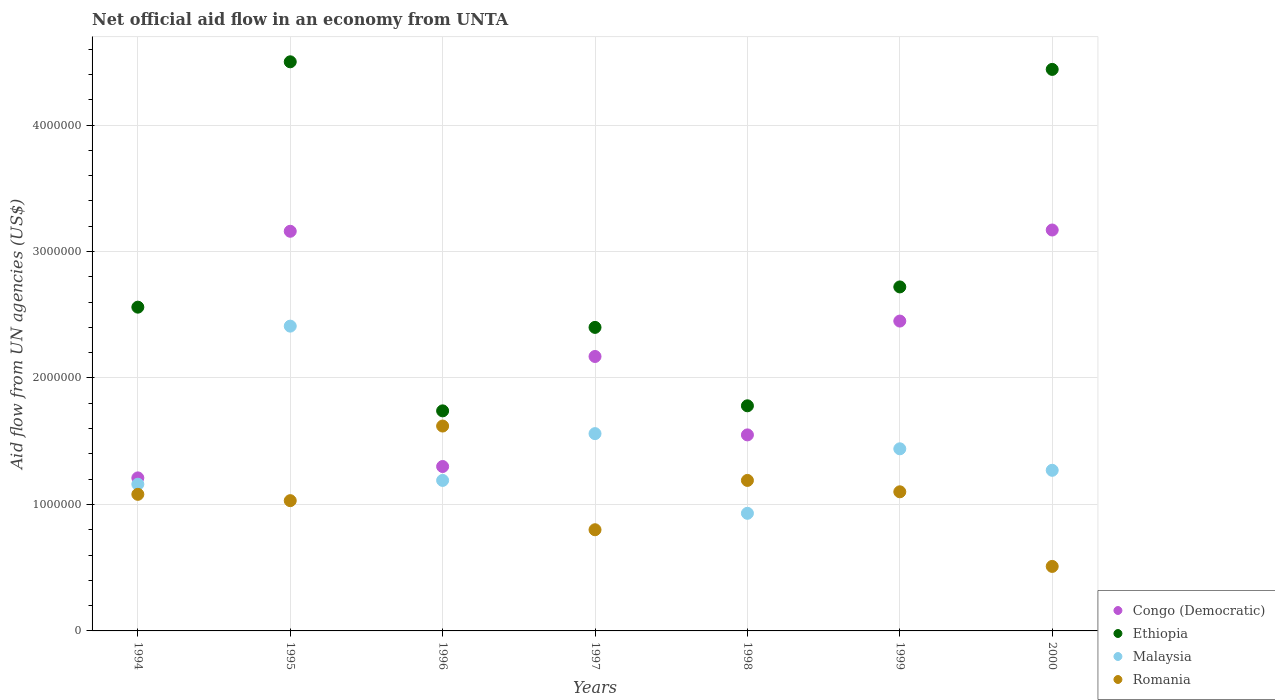What is the net official aid flow in Malaysia in 1999?
Offer a terse response. 1.44e+06. Across all years, what is the maximum net official aid flow in Congo (Democratic)?
Provide a succinct answer. 3.17e+06. Across all years, what is the minimum net official aid flow in Ethiopia?
Offer a terse response. 1.74e+06. What is the total net official aid flow in Congo (Democratic) in the graph?
Provide a short and direct response. 1.50e+07. What is the difference between the net official aid flow in Ethiopia in 1995 and that in 1996?
Your response must be concise. 2.76e+06. What is the difference between the net official aid flow in Romania in 1998 and the net official aid flow in Ethiopia in 2000?
Your response must be concise. -3.25e+06. What is the average net official aid flow in Ethiopia per year?
Your answer should be compact. 2.88e+06. In the year 1994, what is the difference between the net official aid flow in Ethiopia and net official aid flow in Romania?
Your answer should be compact. 1.48e+06. In how many years, is the net official aid flow in Ethiopia greater than 1600000 US$?
Provide a short and direct response. 7. What is the ratio of the net official aid flow in Malaysia in 1994 to that in 1997?
Your answer should be very brief. 0.74. What is the difference between the highest and the second highest net official aid flow in Ethiopia?
Your answer should be compact. 6.00e+04. What is the difference between the highest and the lowest net official aid flow in Romania?
Offer a very short reply. 1.11e+06. In how many years, is the net official aid flow in Romania greater than the average net official aid flow in Romania taken over all years?
Offer a very short reply. 4. Is the sum of the net official aid flow in Malaysia in 1998 and 2000 greater than the maximum net official aid flow in Ethiopia across all years?
Make the answer very short. No. Is it the case that in every year, the sum of the net official aid flow in Ethiopia and net official aid flow in Malaysia  is greater than the sum of net official aid flow in Congo (Democratic) and net official aid flow in Romania?
Provide a short and direct response. Yes. Is it the case that in every year, the sum of the net official aid flow in Malaysia and net official aid flow in Congo (Democratic)  is greater than the net official aid flow in Ethiopia?
Offer a very short reply. No. Is the net official aid flow in Ethiopia strictly less than the net official aid flow in Romania over the years?
Offer a very short reply. No. Where does the legend appear in the graph?
Your answer should be compact. Bottom right. How are the legend labels stacked?
Make the answer very short. Vertical. What is the title of the graph?
Keep it short and to the point. Net official aid flow in an economy from UNTA. Does "Tanzania" appear as one of the legend labels in the graph?
Offer a terse response. No. What is the label or title of the Y-axis?
Offer a very short reply. Aid flow from UN agencies (US$). What is the Aid flow from UN agencies (US$) of Congo (Democratic) in 1994?
Provide a short and direct response. 1.21e+06. What is the Aid flow from UN agencies (US$) in Ethiopia in 1994?
Your answer should be very brief. 2.56e+06. What is the Aid flow from UN agencies (US$) in Malaysia in 1994?
Offer a terse response. 1.16e+06. What is the Aid flow from UN agencies (US$) in Romania in 1994?
Make the answer very short. 1.08e+06. What is the Aid flow from UN agencies (US$) of Congo (Democratic) in 1995?
Offer a terse response. 3.16e+06. What is the Aid flow from UN agencies (US$) of Ethiopia in 1995?
Your response must be concise. 4.50e+06. What is the Aid flow from UN agencies (US$) in Malaysia in 1995?
Give a very brief answer. 2.41e+06. What is the Aid flow from UN agencies (US$) in Romania in 1995?
Give a very brief answer. 1.03e+06. What is the Aid flow from UN agencies (US$) of Congo (Democratic) in 1996?
Your answer should be compact. 1.30e+06. What is the Aid flow from UN agencies (US$) of Ethiopia in 1996?
Provide a succinct answer. 1.74e+06. What is the Aid flow from UN agencies (US$) in Malaysia in 1996?
Provide a succinct answer. 1.19e+06. What is the Aid flow from UN agencies (US$) of Romania in 1996?
Provide a succinct answer. 1.62e+06. What is the Aid flow from UN agencies (US$) in Congo (Democratic) in 1997?
Give a very brief answer. 2.17e+06. What is the Aid flow from UN agencies (US$) of Ethiopia in 1997?
Your answer should be compact. 2.40e+06. What is the Aid flow from UN agencies (US$) in Malaysia in 1997?
Provide a succinct answer. 1.56e+06. What is the Aid flow from UN agencies (US$) in Congo (Democratic) in 1998?
Give a very brief answer. 1.55e+06. What is the Aid flow from UN agencies (US$) of Ethiopia in 1998?
Provide a short and direct response. 1.78e+06. What is the Aid flow from UN agencies (US$) in Malaysia in 1998?
Your answer should be compact. 9.30e+05. What is the Aid flow from UN agencies (US$) in Romania in 1998?
Your response must be concise. 1.19e+06. What is the Aid flow from UN agencies (US$) in Congo (Democratic) in 1999?
Provide a succinct answer. 2.45e+06. What is the Aid flow from UN agencies (US$) of Ethiopia in 1999?
Keep it short and to the point. 2.72e+06. What is the Aid flow from UN agencies (US$) of Malaysia in 1999?
Offer a very short reply. 1.44e+06. What is the Aid flow from UN agencies (US$) of Romania in 1999?
Your answer should be compact. 1.10e+06. What is the Aid flow from UN agencies (US$) in Congo (Democratic) in 2000?
Keep it short and to the point. 3.17e+06. What is the Aid flow from UN agencies (US$) of Ethiopia in 2000?
Provide a succinct answer. 4.44e+06. What is the Aid flow from UN agencies (US$) in Malaysia in 2000?
Your answer should be compact. 1.27e+06. What is the Aid flow from UN agencies (US$) in Romania in 2000?
Offer a very short reply. 5.10e+05. Across all years, what is the maximum Aid flow from UN agencies (US$) of Congo (Democratic)?
Offer a terse response. 3.17e+06. Across all years, what is the maximum Aid flow from UN agencies (US$) of Ethiopia?
Your response must be concise. 4.50e+06. Across all years, what is the maximum Aid flow from UN agencies (US$) in Malaysia?
Provide a succinct answer. 2.41e+06. Across all years, what is the maximum Aid flow from UN agencies (US$) of Romania?
Your answer should be compact. 1.62e+06. Across all years, what is the minimum Aid flow from UN agencies (US$) of Congo (Democratic)?
Offer a terse response. 1.21e+06. Across all years, what is the minimum Aid flow from UN agencies (US$) in Ethiopia?
Your answer should be compact. 1.74e+06. Across all years, what is the minimum Aid flow from UN agencies (US$) in Malaysia?
Keep it short and to the point. 9.30e+05. Across all years, what is the minimum Aid flow from UN agencies (US$) in Romania?
Your answer should be compact. 5.10e+05. What is the total Aid flow from UN agencies (US$) of Congo (Democratic) in the graph?
Your answer should be very brief. 1.50e+07. What is the total Aid flow from UN agencies (US$) of Ethiopia in the graph?
Make the answer very short. 2.01e+07. What is the total Aid flow from UN agencies (US$) of Malaysia in the graph?
Your response must be concise. 9.96e+06. What is the total Aid flow from UN agencies (US$) in Romania in the graph?
Give a very brief answer. 7.33e+06. What is the difference between the Aid flow from UN agencies (US$) in Congo (Democratic) in 1994 and that in 1995?
Offer a terse response. -1.95e+06. What is the difference between the Aid flow from UN agencies (US$) in Ethiopia in 1994 and that in 1995?
Offer a very short reply. -1.94e+06. What is the difference between the Aid flow from UN agencies (US$) of Malaysia in 1994 and that in 1995?
Provide a succinct answer. -1.25e+06. What is the difference between the Aid flow from UN agencies (US$) in Congo (Democratic) in 1994 and that in 1996?
Your answer should be compact. -9.00e+04. What is the difference between the Aid flow from UN agencies (US$) of Ethiopia in 1994 and that in 1996?
Ensure brevity in your answer.  8.20e+05. What is the difference between the Aid flow from UN agencies (US$) in Romania in 1994 and that in 1996?
Provide a short and direct response. -5.40e+05. What is the difference between the Aid flow from UN agencies (US$) in Congo (Democratic) in 1994 and that in 1997?
Give a very brief answer. -9.60e+05. What is the difference between the Aid flow from UN agencies (US$) in Ethiopia in 1994 and that in 1997?
Your response must be concise. 1.60e+05. What is the difference between the Aid flow from UN agencies (US$) in Malaysia in 1994 and that in 1997?
Your answer should be compact. -4.00e+05. What is the difference between the Aid flow from UN agencies (US$) in Romania in 1994 and that in 1997?
Your answer should be compact. 2.80e+05. What is the difference between the Aid flow from UN agencies (US$) in Ethiopia in 1994 and that in 1998?
Offer a very short reply. 7.80e+05. What is the difference between the Aid flow from UN agencies (US$) of Romania in 1994 and that in 1998?
Your response must be concise. -1.10e+05. What is the difference between the Aid flow from UN agencies (US$) of Congo (Democratic) in 1994 and that in 1999?
Your response must be concise. -1.24e+06. What is the difference between the Aid flow from UN agencies (US$) in Ethiopia in 1994 and that in 1999?
Give a very brief answer. -1.60e+05. What is the difference between the Aid flow from UN agencies (US$) of Malaysia in 1994 and that in 1999?
Your response must be concise. -2.80e+05. What is the difference between the Aid flow from UN agencies (US$) of Congo (Democratic) in 1994 and that in 2000?
Ensure brevity in your answer.  -1.96e+06. What is the difference between the Aid flow from UN agencies (US$) of Ethiopia in 1994 and that in 2000?
Your answer should be compact. -1.88e+06. What is the difference between the Aid flow from UN agencies (US$) of Malaysia in 1994 and that in 2000?
Your response must be concise. -1.10e+05. What is the difference between the Aid flow from UN agencies (US$) of Romania in 1994 and that in 2000?
Your answer should be compact. 5.70e+05. What is the difference between the Aid flow from UN agencies (US$) of Congo (Democratic) in 1995 and that in 1996?
Your answer should be compact. 1.86e+06. What is the difference between the Aid flow from UN agencies (US$) of Ethiopia in 1995 and that in 1996?
Offer a terse response. 2.76e+06. What is the difference between the Aid flow from UN agencies (US$) in Malaysia in 1995 and that in 1996?
Your response must be concise. 1.22e+06. What is the difference between the Aid flow from UN agencies (US$) in Romania in 1995 and that in 1996?
Your answer should be compact. -5.90e+05. What is the difference between the Aid flow from UN agencies (US$) of Congo (Democratic) in 1995 and that in 1997?
Offer a very short reply. 9.90e+05. What is the difference between the Aid flow from UN agencies (US$) of Ethiopia in 1995 and that in 1997?
Make the answer very short. 2.10e+06. What is the difference between the Aid flow from UN agencies (US$) in Malaysia in 1995 and that in 1997?
Your answer should be very brief. 8.50e+05. What is the difference between the Aid flow from UN agencies (US$) of Congo (Democratic) in 1995 and that in 1998?
Offer a terse response. 1.61e+06. What is the difference between the Aid flow from UN agencies (US$) of Ethiopia in 1995 and that in 1998?
Your answer should be compact. 2.72e+06. What is the difference between the Aid flow from UN agencies (US$) in Malaysia in 1995 and that in 1998?
Provide a short and direct response. 1.48e+06. What is the difference between the Aid flow from UN agencies (US$) of Romania in 1995 and that in 1998?
Provide a succinct answer. -1.60e+05. What is the difference between the Aid flow from UN agencies (US$) of Congo (Democratic) in 1995 and that in 1999?
Your response must be concise. 7.10e+05. What is the difference between the Aid flow from UN agencies (US$) in Ethiopia in 1995 and that in 1999?
Offer a very short reply. 1.78e+06. What is the difference between the Aid flow from UN agencies (US$) in Malaysia in 1995 and that in 1999?
Your response must be concise. 9.70e+05. What is the difference between the Aid flow from UN agencies (US$) in Congo (Democratic) in 1995 and that in 2000?
Provide a short and direct response. -10000. What is the difference between the Aid flow from UN agencies (US$) of Ethiopia in 1995 and that in 2000?
Offer a terse response. 6.00e+04. What is the difference between the Aid flow from UN agencies (US$) in Malaysia in 1995 and that in 2000?
Provide a succinct answer. 1.14e+06. What is the difference between the Aid flow from UN agencies (US$) in Romania in 1995 and that in 2000?
Your answer should be very brief. 5.20e+05. What is the difference between the Aid flow from UN agencies (US$) in Congo (Democratic) in 1996 and that in 1997?
Provide a short and direct response. -8.70e+05. What is the difference between the Aid flow from UN agencies (US$) of Ethiopia in 1996 and that in 1997?
Give a very brief answer. -6.60e+05. What is the difference between the Aid flow from UN agencies (US$) of Malaysia in 1996 and that in 1997?
Your answer should be compact. -3.70e+05. What is the difference between the Aid flow from UN agencies (US$) in Romania in 1996 and that in 1997?
Your answer should be compact. 8.20e+05. What is the difference between the Aid flow from UN agencies (US$) of Congo (Democratic) in 1996 and that in 1999?
Keep it short and to the point. -1.15e+06. What is the difference between the Aid flow from UN agencies (US$) of Ethiopia in 1996 and that in 1999?
Your response must be concise. -9.80e+05. What is the difference between the Aid flow from UN agencies (US$) in Malaysia in 1996 and that in 1999?
Offer a terse response. -2.50e+05. What is the difference between the Aid flow from UN agencies (US$) of Romania in 1996 and that in 1999?
Keep it short and to the point. 5.20e+05. What is the difference between the Aid flow from UN agencies (US$) of Congo (Democratic) in 1996 and that in 2000?
Ensure brevity in your answer.  -1.87e+06. What is the difference between the Aid flow from UN agencies (US$) of Ethiopia in 1996 and that in 2000?
Offer a very short reply. -2.70e+06. What is the difference between the Aid flow from UN agencies (US$) of Malaysia in 1996 and that in 2000?
Provide a short and direct response. -8.00e+04. What is the difference between the Aid flow from UN agencies (US$) of Romania in 1996 and that in 2000?
Your response must be concise. 1.11e+06. What is the difference between the Aid flow from UN agencies (US$) of Congo (Democratic) in 1997 and that in 1998?
Provide a succinct answer. 6.20e+05. What is the difference between the Aid flow from UN agencies (US$) in Ethiopia in 1997 and that in 1998?
Offer a very short reply. 6.20e+05. What is the difference between the Aid flow from UN agencies (US$) in Malaysia in 1997 and that in 1998?
Give a very brief answer. 6.30e+05. What is the difference between the Aid flow from UN agencies (US$) in Romania in 1997 and that in 1998?
Your response must be concise. -3.90e+05. What is the difference between the Aid flow from UN agencies (US$) in Congo (Democratic) in 1997 and that in 1999?
Keep it short and to the point. -2.80e+05. What is the difference between the Aid flow from UN agencies (US$) in Ethiopia in 1997 and that in 1999?
Offer a very short reply. -3.20e+05. What is the difference between the Aid flow from UN agencies (US$) of Malaysia in 1997 and that in 1999?
Provide a succinct answer. 1.20e+05. What is the difference between the Aid flow from UN agencies (US$) in Ethiopia in 1997 and that in 2000?
Your response must be concise. -2.04e+06. What is the difference between the Aid flow from UN agencies (US$) of Congo (Democratic) in 1998 and that in 1999?
Keep it short and to the point. -9.00e+05. What is the difference between the Aid flow from UN agencies (US$) of Ethiopia in 1998 and that in 1999?
Your response must be concise. -9.40e+05. What is the difference between the Aid flow from UN agencies (US$) of Malaysia in 1998 and that in 1999?
Ensure brevity in your answer.  -5.10e+05. What is the difference between the Aid flow from UN agencies (US$) of Romania in 1998 and that in 1999?
Ensure brevity in your answer.  9.00e+04. What is the difference between the Aid flow from UN agencies (US$) of Congo (Democratic) in 1998 and that in 2000?
Your answer should be compact. -1.62e+06. What is the difference between the Aid flow from UN agencies (US$) in Ethiopia in 1998 and that in 2000?
Offer a terse response. -2.66e+06. What is the difference between the Aid flow from UN agencies (US$) of Romania in 1998 and that in 2000?
Your response must be concise. 6.80e+05. What is the difference between the Aid flow from UN agencies (US$) in Congo (Democratic) in 1999 and that in 2000?
Offer a terse response. -7.20e+05. What is the difference between the Aid flow from UN agencies (US$) of Ethiopia in 1999 and that in 2000?
Your answer should be very brief. -1.72e+06. What is the difference between the Aid flow from UN agencies (US$) in Romania in 1999 and that in 2000?
Offer a very short reply. 5.90e+05. What is the difference between the Aid flow from UN agencies (US$) of Congo (Democratic) in 1994 and the Aid flow from UN agencies (US$) of Ethiopia in 1995?
Provide a succinct answer. -3.29e+06. What is the difference between the Aid flow from UN agencies (US$) of Congo (Democratic) in 1994 and the Aid flow from UN agencies (US$) of Malaysia in 1995?
Your answer should be very brief. -1.20e+06. What is the difference between the Aid flow from UN agencies (US$) in Ethiopia in 1994 and the Aid flow from UN agencies (US$) in Malaysia in 1995?
Keep it short and to the point. 1.50e+05. What is the difference between the Aid flow from UN agencies (US$) of Ethiopia in 1994 and the Aid flow from UN agencies (US$) of Romania in 1995?
Offer a very short reply. 1.53e+06. What is the difference between the Aid flow from UN agencies (US$) in Malaysia in 1994 and the Aid flow from UN agencies (US$) in Romania in 1995?
Your answer should be compact. 1.30e+05. What is the difference between the Aid flow from UN agencies (US$) in Congo (Democratic) in 1994 and the Aid flow from UN agencies (US$) in Ethiopia in 1996?
Your answer should be very brief. -5.30e+05. What is the difference between the Aid flow from UN agencies (US$) of Congo (Democratic) in 1994 and the Aid flow from UN agencies (US$) of Romania in 1996?
Offer a terse response. -4.10e+05. What is the difference between the Aid flow from UN agencies (US$) in Ethiopia in 1994 and the Aid flow from UN agencies (US$) in Malaysia in 1996?
Ensure brevity in your answer.  1.37e+06. What is the difference between the Aid flow from UN agencies (US$) of Ethiopia in 1994 and the Aid flow from UN agencies (US$) of Romania in 1996?
Offer a very short reply. 9.40e+05. What is the difference between the Aid flow from UN agencies (US$) of Malaysia in 1994 and the Aid flow from UN agencies (US$) of Romania in 1996?
Make the answer very short. -4.60e+05. What is the difference between the Aid flow from UN agencies (US$) of Congo (Democratic) in 1994 and the Aid flow from UN agencies (US$) of Ethiopia in 1997?
Give a very brief answer. -1.19e+06. What is the difference between the Aid flow from UN agencies (US$) of Congo (Democratic) in 1994 and the Aid flow from UN agencies (US$) of Malaysia in 1997?
Give a very brief answer. -3.50e+05. What is the difference between the Aid flow from UN agencies (US$) in Congo (Democratic) in 1994 and the Aid flow from UN agencies (US$) in Romania in 1997?
Your answer should be compact. 4.10e+05. What is the difference between the Aid flow from UN agencies (US$) in Ethiopia in 1994 and the Aid flow from UN agencies (US$) in Romania in 1997?
Offer a terse response. 1.76e+06. What is the difference between the Aid flow from UN agencies (US$) of Malaysia in 1994 and the Aid flow from UN agencies (US$) of Romania in 1997?
Provide a succinct answer. 3.60e+05. What is the difference between the Aid flow from UN agencies (US$) in Congo (Democratic) in 1994 and the Aid flow from UN agencies (US$) in Ethiopia in 1998?
Provide a short and direct response. -5.70e+05. What is the difference between the Aid flow from UN agencies (US$) in Congo (Democratic) in 1994 and the Aid flow from UN agencies (US$) in Romania in 1998?
Your answer should be very brief. 2.00e+04. What is the difference between the Aid flow from UN agencies (US$) in Ethiopia in 1994 and the Aid flow from UN agencies (US$) in Malaysia in 1998?
Your answer should be very brief. 1.63e+06. What is the difference between the Aid flow from UN agencies (US$) in Ethiopia in 1994 and the Aid flow from UN agencies (US$) in Romania in 1998?
Your answer should be very brief. 1.37e+06. What is the difference between the Aid flow from UN agencies (US$) of Congo (Democratic) in 1994 and the Aid flow from UN agencies (US$) of Ethiopia in 1999?
Provide a succinct answer. -1.51e+06. What is the difference between the Aid flow from UN agencies (US$) in Congo (Democratic) in 1994 and the Aid flow from UN agencies (US$) in Malaysia in 1999?
Your answer should be very brief. -2.30e+05. What is the difference between the Aid flow from UN agencies (US$) of Congo (Democratic) in 1994 and the Aid flow from UN agencies (US$) of Romania in 1999?
Ensure brevity in your answer.  1.10e+05. What is the difference between the Aid flow from UN agencies (US$) of Ethiopia in 1994 and the Aid flow from UN agencies (US$) of Malaysia in 1999?
Provide a short and direct response. 1.12e+06. What is the difference between the Aid flow from UN agencies (US$) of Ethiopia in 1994 and the Aid flow from UN agencies (US$) of Romania in 1999?
Offer a terse response. 1.46e+06. What is the difference between the Aid flow from UN agencies (US$) in Congo (Democratic) in 1994 and the Aid flow from UN agencies (US$) in Ethiopia in 2000?
Your answer should be very brief. -3.23e+06. What is the difference between the Aid flow from UN agencies (US$) in Congo (Democratic) in 1994 and the Aid flow from UN agencies (US$) in Malaysia in 2000?
Keep it short and to the point. -6.00e+04. What is the difference between the Aid flow from UN agencies (US$) of Congo (Democratic) in 1994 and the Aid flow from UN agencies (US$) of Romania in 2000?
Provide a short and direct response. 7.00e+05. What is the difference between the Aid flow from UN agencies (US$) in Ethiopia in 1994 and the Aid flow from UN agencies (US$) in Malaysia in 2000?
Offer a terse response. 1.29e+06. What is the difference between the Aid flow from UN agencies (US$) in Ethiopia in 1994 and the Aid flow from UN agencies (US$) in Romania in 2000?
Give a very brief answer. 2.05e+06. What is the difference between the Aid flow from UN agencies (US$) in Malaysia in 1994 and the Aid flow from UN agencies (US$) in Romania in 2000?
Offer a very short reply. 6.50e+05. What is the difference between the Aid flow from UN agencies (US$) in Congo (Democratic) in 1995 and the Aid flow from UN agencies (US$) in Ethiopia in 1996?
Keep it short and to the point. 1.42e+06. What is the difference between the Aid flow from UN agencies (US$) of Congo (Democratic) in 1995 and the Aid flow from UN agencies (US$) of Malaysia in 1996?
Keep it short and to the point. 1.97e+06. What is the difference between the Aid flow from UN agencies (US$) in Congo (Democratic) in 1995 and the Aid flow from UN agencies (US$) in Romania in 1996?
Keep it short and to the point. 1.54e+06. What is the difference between the Aid flow from UN agencies (US$) of Ethiopia in 1995 and the Aid flow from UN agencies (US$) of Malaysia in 1996?
Give a very brief answer. 3.31e+06. What is the difference between the Aid flow from UN agencies (US$) of Ethiopia in 1995 and the Aid flow from UN agencies (US$) of Romania in 1996?
Provide a succinct answer. 2.88e+06. What is the difference between the Aid flow from UN agencies (US$) of Malaysia in 1995 and the Aid flow from UN agencies (US$) of Romania in 1996?
Ensure brevity in your answer.  7.90e+05. What is the difference between the Aid flow from UN agencies (US$) of Congo (Democratic) in 1995 and the Aid flow from UN agencies (US$) of Ethiopia in 1997?
Keep it short and to the point. 7.60e+05. What is the difference between the Aid flow from UN agencies (US$) in Congo (Democratic) in 1995 and the Aid flow from UN agencies (US$) in Malaysia in 1997?
Provide a succinct answer. 1.60e+06. What is the difference between the Aid flow from UN agencies (US$) in Congo (Democratic) in 1995 and the Aid flow from UN agencies (US$) in Romania in 1997?
Provide a succinct answer. 2.36e+06. What is the difference between the Aid flow from UN agencies (US$) of Ethiopia in 1995 and the Aid flow from UN agencies (US$) of Malaysia in 1997?
Provide a succinct answer. 2.94e+06. What is the difference between the Aid flow from UN agencies (US$) in Ethiopia in 1995 and the Aid flow from UN agencies (US$) in Romania in 1997?
Your response must be concise. 3.70e+06. What is the difference between the Aid flow from UN agencies (US$) of Malaysia in 1995 and the Aid flow from UN agencies (US$) of Romania in 1997?
Provide a short and direct response. 1.61e+06. What is the difference between the Aid flow from UN agencies (US$) in Congo (Democratic) in 1995 and the Aid flow from UN agencies (US$) in Ethiopia in 1998?
Make the answer very short. 1.38e+06. What is the difference between the Aid flow from UN agencies (US$) in Congo (Democratic) in 1995 and the Aid flow from UN agencies (US$) in Malaysia in 1998?
Make the answer very short. 2.23e+06. What is the difference between the Aid flow from UN agencies (US$) of Congo (Democratic) in 1995 and the Aid flow from UN agencies (US$) of Romania in 1998?
Your response must be concise. 1.97e+06. What is the difference between the Aid flow from UN agencies (US$) of Ethiopia in 1995 and the Aid flow from UN agencies (US$) of Malaysia in 1998?
Give a very brief answer. 3.57e+06. What is the difference between the Aid flow from UN agencies (US$) in Ethiopia in 1995 and the Aid flow from UN agencies (US$) in Romania in 1998?
Your response must be concise. 3.31e+06. What is the difference between the Aid flow from UN agencies (US$) of Malaysia in 1995 and the Aid flow from UN agencies (US$) of Romania in 1998?
Your answer should be compact. 1.22e+06. What is the difference between the Aid flow from UN agencies (US$) of Congo (Democratic) in 1995 and the Aid flow from UN agencies (US$) of Ethiopia in 1999?
Provide a short and direct response. 4.40e+05. What is the difference between the Aid flow from UN agencies (US$) in Congo (Democratic) in 1995 and the Aid flow from UN agencies (US$) in Malaysia in 1999?
Your answer should be very brief. 1.72e+06. What is the difference between the Aid flow from UN agencies (US$) of Congo (Democratic) in 1995 and the Aid flow from UN agencies (US$) of Romania in 1999?
Your answer should be very brief. 2.06e+06. What is the difference between the Aid flow from UN agencies (US$) of Ethiopia in 1995 and the Aid flow from UN agencies (US$) of Malaysia in 1999?
Make the answer very short. 3.06e+06. What is the difference between the Aid flow from UN agencies (US$) in Ethiopia in 1995 and the Aid flow from UN agencies (US$) in Romania in 1999?
Offer a terse response. 3.40e+06. What is the difference between the Aid flow from UN agencies (US$) of Malaysia in 1995 and the Aid flow from UN agencies (US$) of Romania in 1999?
Your answer should be very brief. 1.31e+06. What is the difference between the Aid flow from UN agencies (US$) in Congo (Democratic) in 1995 and the Aid flow from UN agencies (US$) in Ethiopia in 2000?
Offer a very short reply. -1.28e+06. What is the difference between the Aid flow from UN agencies (US$) of Congo (Democratic) in 1995 and the Aid flow from UN agencies (US$) of Malaysia in 2000?
Provide a short and direct response. 1.89e+06. What is the difference between the Aid flow from UN agencies (US$) of Congo (Democratic) in 1995 and the Aid flow from UN agencies (US$) of Romania in 2000?
Keep it short and to the point. 2.65e+06. What is the difference between the Aid flow from UN agencies (US$) of Ethiopia in 1995 and the Aid flow from UN agencies (US$) of Malaysia in 2000?
Ensure brevity in your answer.  3.23e+06. What is the difference between the Aid flow from UN agencies (US$) of Ethiopia in 1995 and the Aid flow from UN agencies (US$) of Romania in 2000?
Offer a very short reply. 3.99e+06. What is the difference between the Aid flow from UN agencies (US$) of Malaysia in 1995 and the Aid flow from UN agencies (US$) of Romania in 2000?
Give a very brief answer. 1.90e+06. What is the difference between the Aid flow from UN agencies (US$) in Congo (Democratic) in 1996 and the Aid flow from UN agencies (US$) in Ethiopia in 1997?
Your answer should be compact. -1.10e+06. What is the difference between the Aid flow from UN agencies (US$) of Congo (Democratic) in 1996 and the Aid flow from UN agencies (US$) of Malaysia in 1997?
Provide a succinct answer. -2.60e+05. What is the difference between the Aid flow from UN agencies (US$) of Ethiopia in 1996 and the Aid flow from UN agencies (US$) of Malaysia in 1997?
Provide a succinct answer. 1.80e+05. What is the difference between the Aid flow from UN agencies (US$) of Ethiopia in 1996 and the Aid flow from UN agencies (US$) of Romania in 1997?
Offer a very short reply. 9.40e+05. What is the difference between the Aid flow from UN agencies (US$) of Congo (Democratic) in 1996 and the Aid flow from UN agencies (US$) of Ethiopia in 1998?
Your answer should be very brief. -4.80e+05. What is the difference between the Aid flow from UN agencies (US$) in Ethiopia in 1996 and the Aid flow from UN agencies (US$) in Malaysia in 1998?
Keep it short and to the point. 8.10e+05. What is the difference between the Aid flow from UN agencies (US$) of Ethiopia in 1996 and the Aid flow from UN agencies (US$) of Romania in 1998?
Provide a succinct answer. 5.50e+05. What is the difference between the Aid flow from UN agencies (US$) in Congo (Democratic) in 1996 and the Aid flow from UN agencies (US$) in Ethiopia in 1999?
Provide a succinct answer. -1.42e+06. What is the difference between the Aid flow from UN agencies (US$) in Ethiopia in 1996 and the Aid flow from UN agencies (US$) in Malaysia in 1999?
Ensure brevity in your answer.  3.00e+05. What is the difference between the Aid flow from UN agencies (US$) of Ethiopia in 1996 and the Aid flow from UN agencies (US$) of Romania in 1999?
Provide a succinct answer. 6.40e+05. What is the difference between the Aid flow from UN agencies (US$) of Congo (Democratic) in 1996 and the Aid flow from UN agencies (US$) of Ethiopia in 2000?
Give a very brief answer. -3.14e+06. What is the difference between the Aid flow from UN agencies (US$) of Congo (Democratic) in 1996 and the Aid flow from UN agencies (US$) of Romania in 2000?
Your answer should be very brief. 7.90e+05. What is the difference between the Aid flow from UN agencies (US$) of Ethiopia in 1996 and the Aid flow from UN agencies (US$) of Romania in 2000?
Offer a terse response. 1.23e+06. What is the difference between the Aid flow from UN agencies (US$) in Malaysia in 1996 and the Aid flow from UN agencies (US$) in Romania in 2000?
Your answer should be compact. 6.80e+05. What is the difference between the Aid flow from UN agencies (US$) in Congo (Democratic) in 1997 and the Aid flow from UN agencies (US$) in Malaysia in 1998?
Your answer should be compact. 1.24e+06. What is the difference between the Aid flow from UN agencies (US$) in Congo (Democratic) in 1997 and the Aid flow from UN agencies (US$) in Romania in 1998?
Your answer should be compact. 9.80e+05. What is the difference between the Aid flow from UN agencies (US$) of Ethiopia in 1997 and the Aid flow from UN agencies (US$) of Malaysia in 1998?
Offer a terse response. 1.47e+06. What is the difference between the Aid flow from UN agencies (US$) in Ethiopia in 1997 and the Aid flow from UN agencies (US$) in Romania in 1998?
Provide a succinct answer. 1.21e+06. What is the difference between the Aid flow from UN agencies (US$) of Congo (Democratic) in 1997 and the Aid flow from UN agencies (US$) of Ethiopia in 1999?
Offer a terse response. -5.50e+05. What is the difference between the Aid flow from UN agencies (US$) in Congo (Democratic) in 1997 and the Aid flow from UN agencies (US$) in Malaysia in 1999?
Offer a very short reply. 7.30e+05. What is the difference between the Aid flow from UN agencies (US$) of Congo (Democratic) in 1997 and the Aid flow from UN agencies (US$) of Romania in 1999?
Provide a short and direct response. 1.07e+06. What is the difference between the Aid flow from UN agencies (US$) in Ethiopia in 1997 and the Aid flow from UN agencies (US$) in Malaysia in 1999?
Your response must be concise. 9.60e+05. What is the difference between the Aid flow from UN agencies (US$) of Ethiopia in 1997 and the Aid flow from UN agencies (US$) of Romania in 1999?
Offer a terse response. 1.30e+06. What is the difference between the Aid flow from UN agencies (US$) in Malaysia in 1997 and the Aid flow from UN agencies (US$) in Romania in 1999?
Your answer should be very brief. 4.60e+05. What is the difference between the Aid flow from UN agencies (US$) in Congo (Democratic) in 1997 and the Aid flow from UN agencies (US$) in Ethiopia in 2000?
Your answer should be compact. -2.27e+06. What is the difference between the Aid flow from UN agencies (US$) in Congo (Democratic) in 1997 and the Aid flow from UN agencies (US$) in Romania in 2000?
Provide a succinct answer. 1.66e+06. What is the difference between the Aid flow from UN agencies (US$) in Ethiopia in 1997 and the Aid flow from UN agencies (US$) in Malaysia in 2000?
Give a very brief answer. 1.13e+06. What is the difference between the Aid flow from UN agencies (US$) of Ethiopia in 1997 and the Aid flow from UN agencies (US$) of Romania in 2000?
Your answer should be compact. 1.89e+06. What is the difference between the Aid flow from UN agencies (US$) of Malaysia in 1997 and the Aid flow from UN agencies (US$) of Romania in 2000?
Ensure brevity in your answer.  1.05e+06. What is the difference between the Aid flow from UN agencies (US$) of Congo (Democratic) in 1998 and the Aid flow from UN agencies (US$) of Ethiopia in 1999?
Give a very brief answer. -1.17e+06. What is the difference between the Aid flow from UN agencies (US$) in Congo (Democratic) in 1998 and the Aid flow from UN agencies (US$) in Romania in 1999?
Your answer should be compact. 4.50e+05. What is the difference between the Aid flow from UN agencies (US$) in Ethiopia in 1998 and the Aid flow from UN agencies (US$) in Malaysia in 1999?
Make the answer very short. 3.40e+05. What is the difference between the Aid flow from UN agencies (US$) of Ethiopia in 1998 and the Aid flow from UN agencies (US$) of Romania in 1999?
Make the answer very short. 6.80e+05. What is the difference between the Aid flow from UN agencies (US$) of Congo (Democratic) in 1998 and the Aid flow from UN agencies (US$) of Ethiopia in 2000?
Ensure brevity in your answer.  -2.89e+06. What is the difference between the Aid flow from UN agencies (US$) in Congo (Democratic) in 1998 and the Aid flow from UN agencies (US$) in Malaysia in 2000?
Your response must be concise. 2.80e+05. What is the difference between the Aid flow from UN agencies (US$) in Congo (Democratic) in 1998 and the Aid flow from UN agencies (US$) in Romania in 2000?
Keep it short and to the point. 1.04e+06. What is the difference between the Aid flow from UN agencies (US$) in Ethiopia in 1998 and the Aid flow from UN agencies (US$) in Malaysia in 2000?
Provide a short and direct response. 5.10e+05. What is the difference between the Aid flow from UN agencies (US$) of Ethiopia in 1998 and the Aid flow from UN agencies (US$) of Romania in 2000?
Provide a succinct answer. 1.27e+06. What is the difference between the Aid flow from UN agencies (US$) of Malaysia in 1998 and the Aid flow from UN agencies (US$) of Romania in 2000?
Give a very brief answer. 4.20e+05. What is the difference between the Aid flow from UN agencies (US$) of Congo (Democratic) in 1999 and the Aid flow from UN agencies (US$) of Ethiopia in 2000?
Offer a terse response. -1.99e+06. What is the difference between the Aid flow from UN agencies (US$) of Congo (Democratic) in 1999 and the Aid flow from UN agencies (US$) of Malaysia in 2000?
Keep it short and to the point. 1.18e+06. What is the difference between the Aid flow from UN agencies (US$) of Congo (Democratic) in 1999 and the Aid flow from UN agencies (US$) of Romania in 2000?
Your answer should be very brief. 1.94e+06. What is the difference between the Aid flow from UN agencies (US$) in Ethiopia in 1999 and the Aid flow from UN agencies (US$) in Malaysia in 2000?
Give a very brief answer. 1.45e+06. What is the difference between the Aid flow from UN agencies (US$) in Ethiopia in 1999 and the Aid flow from UN agencies (US$) in Romania in 2000?
Provide a short and direct response. 2.21e+06. What is the difference between the Aid flow from UN agencies (US$) of Malaysia in 1999 and the Aid flow from UN agencies (US$) of Romania in 2000?
Provide a short and direct response. 9.30e+05. What is the average Aid flow from UN agencies (US$) in Congo (Democratic) per year?
Your response must be concise. 2.14e+06. What is the average Aid flow from UN agencies (US$) of Ethiopia per year?
Offer a terse response. 2.88e+06. What is the average Aid flow from UN agencies (US$) in Malaysia per year?
Your response must be concise. 1.42e+06. What is the average Aid flow from UN agencies (US$) in Romania per year?
Offer a very short reply. 1.05e+06. In the year 1994, what is the difference between the Aid flow from UN agencies (US$) in Congo (Democratic) and Aid flow from UN agencies (US$) in Ethiopia?
Offer a terse response. -1.35e+06. In the year 1994, what is the difference between the Aid flow from UN agencies (US$) of Congo (Democratic) and Aid flow from UN agencies (US$) of Malaysia?
Your answer should be very brief. 5.00e+04. In the year 1994, what is the difference between the Aid flow from UN agencies (US$) of Congo (Democratic) and Aid flow from UN agencies (US$) of Romania?
Provide a short and direct response. 1.30e+05. In the year 1994, what is the difference between the Aid flow from UN agencies (US$) in Ethiopia and Aid flow from UN agencies (US$) in Malaysia?
Provide a short and direct response. 1.40e+06. In the year 1994, what is the difference between the Aid flow from UN agencies (US$) of Ethiopia and Aid flow from UN agencies (US$) of Romania?
Provide a succinct answer. 1.48e+06. In the year 1995, what is the difference between the Aid flow from UN agencies (US$) of Congo (Democratic) and Aid flow from UN agencies (US$) of Ethiopia?
Offer a terse response. -1.34e+06. In the year 1995, what is the difference between the Aid flow from UN agencies (US$) of Congo (Democratic) and Aid flow from UN agencies (US$) of Malaysia?
Your answer should be very brief. 7.50e+05. In the year 1995, what is the difference between the Aid flow from UN agencies (US$) in Congo (Democratic) and Aid flow from UN agencies (US$) in Romania?
Keep it short and to the point. 2.13e+06. In the year 1995, what is the difference between the Aid flow from UN agencies (US$) in Ethiopia and Aid flow from UN agencies (US$) in Malaysia?
Offer a very short reply. 2.09e+06. In the year 1995, what is the difference between the Aid flow from UN agencies (US$) of Ethiopia and Aid flow from UN agencies (US$) of Romania?
Offer a terse response. 3.47e+06. In the year 1995, what is the difference between the Aid flow from UN agencies (US$) of Malaysia and Aid flow from UN agencies (US$) of Romania?
Offer a very short reply. 1.38e+06. In the year 1996, what is the difference between the Aid flow from UN agencies (US$) of Congo (Democratic) and Aid flow from UN agencies (US$) of Ethiopia?
Provide a short and direct response. -4.40e+05. In the year 1996, what is the difference between the Aid flow from UN agencies (US$) in Congo (Democratic) and Aid flow from UN agencies (US$) in Romania?
Your response must be concise. -3.20e+05. In the year 1996, what is the difference between the Aid flow from UN agencies (US$) in Malaysia and Aid flow from UN agencies (US$) in Romania?
Offer a very short reply. -4.30e+05. In the year 1997, what is the difference between the Aid flow from UN agencies (US$) in Congo (Democratic) and Aid flow from UN agencies (US$) in Romania?
Your response must be concise. 1.37e+06. In the year 1997, what is the difference between the Aid flow from UN agencies (US$) in Ethiopia and Aid flow from UN agencies (US$) in Malaysia?
Ensure brevity in your answer.  8.40e+05. In the year 1997, what is the difference between the Aid flow from UN agencies (US$) of Ethiopia and Aid flow from UN agencies (US$) of Romania?
Provide a succinct answer. 1.60e+06. In the year 1997, what is the difference between the Aid flow from UN agencies (US$) in Malaysia and Aid flow from UN agencies (US$) in Romania?
Offer a terse response. 7.60e+05. In the year 1998, what is the difference between the Aid flow from UN agencies (US$) of Congo (Democratic) and Aid flow from UN agencies (US$) of Ethiopia?
Give a very brief answer. -2.30e+05. In the year 1998, what is the difference between the Aid flow from UN agencies (US$) of Congo (Democratic) and Aid flow from UN agencies (US$) of Malaysia?
Your answer should be very brief. 6.20e+05. In the year 1998, what is the difference between the Aid flow from UN agencies (US$) in Congo (Democratic) and Aid flow from UN agencies (US$) in Romania?
Make the answer very short. 3.60e+05. In the year 1998, what is the difference between the Aid flow from UN agencies (US$) in Ethiopia and Aid flow from UN agencies (US$) in Malaysia?
Provide a succinct answer. 8.50e+05. In the year 1998, what is the difference between the Aid flow from UN agencies (US$) in Ethiopia and Aid flow from UN agencies (US$) in Romania?
Your response must be concise. 5.90e+05. In the year 1999, what is the difference between the Aid flow from UN agencies (US$) in Congo (Democratic) and Aid flow from UN agencies (US$) in Ethiopia?
Your response must be concise. -2.70e+05. In the year 1999, what is the difference between the Aid flow from UN agencies (US$) in Congo (Democratic) and Aid flow from UN agencies (US$) in Malaysia?
Provide a short and direct response. 1.01e+06. In the year 1999, what is the difference between the Aid flow from UN agencies (US$) of Congo (Democratic) and Aid flow from UN agencies (US$) of Romania?
Offer a terse response. 1.35e+06. In the year 1999, what is the difference between the Aid flow from UN agencies (US$) of Ethiopia and Aid flow from UN agencies (US$) of Malaysia?
Keep it short and to the point. 1.28e+06. In the year 1999, what is the difference between the Aid flow from UN agencies (US$) in Ethiopia and Aid flow from UN agencies (US$) in Romania?
Make the answer very short. 1.62e+06. In the year 2000, what is the difference between the Aid flow from UN agencies (US$) of Congo (Democratic) and Aid flow from UN agencies (US$) of Ethiopia?
Keep it short and to the point. -1.27e+06. In the year 2000, what is the difference between the Aid flow from UN agencies (US$) in Congo (Democratic) and Aid flow from UN agencies (US$) in Malaysia?
Your answer should be very brief. 1.90e+06. In the year 2000, what is the difference between the Aid flow from UN agencies (US$) of Congo (Democratic) and Aid flow from UN agencies (US$) of Romania?
Your answer should be compact. 2.66e+06. In the year 2000, what is the difference between the Aid flow from UN agencies (US$) of Ethiopia and Aid flow from UN agencies (US$) of Malaysia?
Keep it short and to the point. 3.17e+06. In the year 2000, what is the difference between the Aid flow from UN agencies (US$) in Ethiopia and Aid flow from UN agencies (US$) in Romania?
Provide a short and direct response. 3.93e+06. In the year 2000, what is the difference between the Aid flow from UN agencies (US$) of Malaysia and Aid flow from UN agencies (US$) of Romania?
Offer a very short reply. 7.60e+05. What is the ratio of the Aid flow from UN agencies (US$) in Congo (Democratic) in 1994 to that in 1995?
Your answer should be compact. 0.38. What is the ratio of the Aid flow from UN agencies (US$) in Ethiopia in 1994 to that in 1995?
Offer a terse response. 0.57. What is the ratio of the Aid flow from UN agencies (US$) in Malaysia in 1994 to that in 1995?
Provide a succinct answer. 0.48. What is the ratio of the Aid flow from UN agencies (US$) of Romania in 1994 to that in 1995?
Ensure brevity in your answer.  1.05. What is the ratio of the Aid flow from UN agencies (US$) in Congo (Democratic) in 1994 to that in 1996?
Ensure brevity in your answer.  0.93. What is the ratio of the Aid flow from UN agencies (US$) of Ethiopia in 1994 to that in 1996?
Provide a short and direct response. 1.47. What is the ratio of the Aid flow from UN agencies (US$) of Malaysia in 1994 to that in 1996?
Your answer should be compact. 0.97. What is the ratio of the Aid flow from UN agencies (US$) of Congo (Democratic) in 1994 to that in 1997?
Provide a short and direct response. 0.56. What is the ratio of the Aid flow from UN agencies (US$) in Ethiopia in 1994 to that in 1997?
Offer a terse response. 1.07. What is the ratio of the Aid flow from UN agencies (US$) of Malaysia in 1994 to that in 1997?
Offer a terse response. 0.74. What is the ratio of the Aid flow from UN agencies (US$) in Romania in 1994 to that in 1997?
Provide a succinct answer. 1.35. What is the ratio of the Aid flow from UN agencies (US$) in Congo (Democratic) in 1994 to that in 1998?
Make the answer very short. 0.78. What is the ratio of the Aid flow from UN agencies (US$) in Ethiopia in 1994 to that in 1998?
Make the answer very short. 1.44. What is the ratio of the Aid flow from UN agencies (US$) of Malaysia in 1994 to that in 1998?
Ensure brevity in your answer.  1.25. What is the ratio of the Aid flow from UN agencies (US$) in Romania in 1994 to that in 1998?
Make the answer very short. 0.91. What is the ratio of the Aid flow from UN agencies (US$) of Congo (Democratic) in 1994 to that in 1999?
Provide a succinct answer. 0.49. What is the ratio of the Aid flow from UN agencies (US$) of Malaysia in 1994 to that in 1999?
Keep it short and to the point. 0.81. What is the ratio of the Aid flow from UN agencies (US$) of Romania in 1994 to that in 1999?
Provide a succinct answer. 0.98. What is the ratio of the Aid flow from UN agencies (US$) of Congo (Democratic) in 1994 to that in 2000?
Offer a very short reply. 0.38. What is the ratio of the Aid flow from UN agencies (US$) of Ethiopia in 1994 to that in 2000?
Make the answer very short. 0.58. What is the ratio of the Aid flow from UN agencies (US$) of Malaysia in 1994 to that in 2000?
Your answer should be compact. 0.91. What is the ratio of the Aid flow from UN agencies (US$) in Romania in 1994 to that in 2000?
Your response must be concise. 2.12. What is the ratio of the Aid flow from UN agencies (US$) in Congo (Democratic) in 1995 to that in 1996?
Your response must be concise. 2.43. What is the ratio of the Aid flow from UN agencies (US$) of Ethiopia in 1995 to that in 1996?
Make the answer very short. 2.59. What is the ratio of the Aid flow from UN agencies (US$) of Malaysia in 1995 to that in 1996?
Make the answer very short. 2.03. What is the ratio of the Aid flow from UN agencies (US$) of Romania in 1995 to that in 1996?
Offer a terse response. 0.64. What is the ratio of the Aid flow from UN agencies (US$) in Congo (Democratic) in 1995 to that in 1997?
Give a very brief answer. 1.46. What is the ratio of the Aid flow from UN agencies (US$) of Ethiopia in 1995 to that in 1997?
Offer a terse response. 1.88. What is the ratio of the Aid flow from UN agencies (US$) in Malaysia in 1995 to that in 1997?
Your answer should be very brief. 1.54. What is the ratio of the Aid flow from UN agencies (US$) of Romania in 1995 to that in 1997?
Provide a short and direct response. 1.29. What is the ratio of the Aid flow from UN agencies (US$) in Congo (Democratic) in 1995 to that in 1998?
Provide a short and direct response. 2.04. What is the ratio of the Aid flow from UN agencies (US$) in Ethiopia in 1995 to that in 1998?
Keep it short and to the point. 2.53. What is the ratio of the Aid flow from UN agencies (US$) of Malaysia in 1995 to that in 1998?
Give a very brief answer. 2.59. What is the ratio of the Aid flow from UN agencies (US$) in Romania in 1995 to that in 1998?
Your answer should be compact. 0.87. What is the ratio of the Aid flow from UN agencies (US$) in Congo (Democratic) in 1995 to that in 1999?
Offer a terse response. 1.29. What is the ratio of the Aid flow from UN agencies (US$) of Ethiopia in 1995 to that in 1999?
Provide a succinct answer. 1.65. What is the ratio of the Aid flow from UN agencies (US$) in Malaysia in 1995 to that in 1999?
Ensure brevity in your answer.  1.67. What is the ratio of the Aid flow from UN agencies (US$) in Romania in 1995 to that in 1999?
Make the answer very short. 0.94. What is the ratio of the Aid flow from UN agencies (US$) in Ethiopia in 1995 to that in 2000?
Give a very brief answer. 1.01. What is the ratio of the Aid flow from UN agencies (US$) of Malaysia in 1995 to that in 2000?
Your answer should be very brief. 1.9. What is the ratio of the Aid flow from UN agencies (US$) in Romania in 1995 to that in 2000?
Keep it short and to the point. 2.02. What is the ratio of the Aid flow from UN agencies (US$) in Congo (Democratic) in 1996 to that in 1997?
Provide a short and direct response. 0.6. What is the ratio of the Aid flow from UN agencies (US$) in Ethiopia in 1996 to that in 1997?
Your response must be concise. 0.72. What is the ratio of the Aid flow from UN agencies (US$) in Malaysia in 1996 to that in 1997?
Your answer should be compact. 0.76. What is the ratio of the Aid flow from UN agencies (US$) of Romania in 1996 to that in 1997?
Your response must be concise. 2.02. What is the ratio of the Aid flow from UN agencies (US$) in Congo (Democratic) in 1996 to that in 1998?
Offer a terse response. 0.84. What is the ratio of the Aid flow from UN agencies (US$) in Ethiopia in 1996 to that in 1998?
Offer a very short reply. 0.98. What is the ratio of the Aid flow from UN agencies (US$) of Malaysia in 1996 to that in 1998?
Ensure brevity in your answer.  1.28. What is the ratio of the Aid flow from UN agencies (US$) in Romania in 1996 to that in 1998?
Provide a succinct answer. 1.36. What is the ratio of the Aid flow from UN agencies (US$) in Congo (Democratic) in 1996 to that in 1999?
Your answer should be compact. 0.53. What is the ratio of the Aid flow from UN agencies (US$) of Ethiopia in 1996 to that in 1999?
Provide a succinct answer. 0.64. What is the ratio of the Aid flow from UN agencies (US$) in Malaysia in 1996 to that in 1999?
Keep it short and to the point. 0.83. What is the ratio of the Aid flow from UN agencies (US$) of Romania in 1996 to that in 1999?
Give a very brief answer. 1.47. What is the ratio of the Aid flow from UN agencies (US$) of Congo (Democratic) in 1996 to that in 2000?
Give a very brief answer. 0.41. What is the ratio of the Aid flow from UN agencies (US$) in Ethiopia in 1996 to that in 2000?
Keep it short and to the point. 0.39. What is the ratio of the Aid flow from UN agencies (US$) of Malaysia in 1996 to that in 2000?
Ensure brevity in your answer.  0.94. What is the ratio of the Aid flow from UN agencies (US$) of Romania in 1996 to that in 2000?
Your answer should be compact. 3.18. What is the ratio of the Aid flow from UN agencies (US$) of Ethiopia in 1997 to that in 1998?
Provide a succinct answer. 1.35. What is the ratio of the Aid flow from UN agencies (US$) of Malaysia in 1997 to that in 1998?
Ensure brevity in your answer.  1.68. What is the ratio of the Aid flow from UN agencies (US$) of Romania in 1997 to that in 1998?
Your response must be concise. 0.67. What is the ratio of the Aid flow from UN agencies (US$) in Congo (Democratic) in 1997 to that in 1999?
Your answer should be compact. 0.89. What is the ratio of the Aid flow from UN agencies (US$) of Ethiopia in 1997 to that in 1999?
Provide a succinct answer. 0.88. What is the ratio of the Aid flow from UN agencies (US$) in Romania in 1997 to that in 1999?
Give a very brief answer. 0.73. What is the ratio of the Aid flow from UN agencies (US$) of Congo (Democratic) in 1997 to that in 2000?
Make the answer very short. 0.68. What is the ratio of the Aid flow from UN agencies (US$) in Ethiopia in 1997 to that in 2000?
Give a very brief answer. 0.54. What is the ratio of the Aid flow from UN agencies (US$) of Malaysia in 1997 to that in 2000?
Offer a terse response. 1.23. What is the ratio of the Aid flow from UN agencies (US$) of Romania in 1997 to that in 2000?
Give a very brief answer. 1.57. What is the ratio of the Aid flow from UN agencies (US$) in Congo (Democratic) in 1998 to that in 1999?
Provide a short and direct response. 0.63. What is the ratio of the Aid flow from UN agencies (US$) of Ethiopia in 1998 to that in 1999?
Make the answer very short. 0.65. What is the ratio of the Aid flow from UN agencies (US$) of Malaysia in 1998 to that in 1999?
Provide a succinct answer. 0.65. What is the ratio of the Aid flow from UN agencies (US$) in Romania in 1998 to that in 1999?
Offer a very short reply. 1.08. What is the ratio of the Aid flow from UN agencies (US$) in Congo (Democratic) in 1998 to that in 2000?
Ensure brevity in your answer.  0.49. What is the ratio of the Aid flow from UN agencies (US$) in Ethiopia in 1998 to that in 2000?
Provide a succinct answer. 0.4. What is the ratio of the Aid flow from UN agencies (US$) of Malaysia in 1998 to that in 2000?
Make the answer very short. 0.73. What is the ratio of the Aid flow from UN agencies (US$) of Romania in 1998 to that in 2000?
Your answer should be very brief. 2.33. What is the ratio of the Aid flow from UN agencies (US$) in Congo (Democratic) in 1999 to that in 2000?
Your answer should be compact. 0.77. What is the ratio of the Aid flow from UN agencies (US$) of Ethiopia in 1999 to that in 2000?
Provide a short and direct response. 0.61. What is the ratio of the Aid flow from UN agencies (US$) of Malaysia in 1999 to that in 2000?
Your answer should be compact. 1.13. What is the ratio of the Aid flow from UN agencies (US$) in Romania in 1999 to that in 2000?
Provide a succinct answer. 2.16. What is the difference between the highest and the second highest Aid flow from UN agencies (US$) in Ethiopia?
Offer a terse response. 6.00e+04. What is the difference between the highest and the second highest Aid flow from UN agencies (US$) in Malaysia?
Your answer should be compact. 8.50e+05. What is the difference between the highest and the second highest Aid flow from UN agencies (US$) in Romania?
Provide a succinct answer. 4.30e+05. What is the difference between the highest and the lowest Aid flow from UN agencies (US$) of Congo (Democratic)?
Your answer should be compact. 1.96e+06. What is the difference between the highest and the lowest Aid flow from UN agencies (US$) in Ethiopia?
Offer a very short reply. 2.76e+06. What is the difference between the highest and the lowest Aid flow from UN agencies (US$) of Malaysia?
Ensure brevity in your answer.  1.48e+06. What is the difference between the highest and the lowest Aid flow from UN agencies (US$) in Romania?
Your answer should be compact. 1.11e+06. 